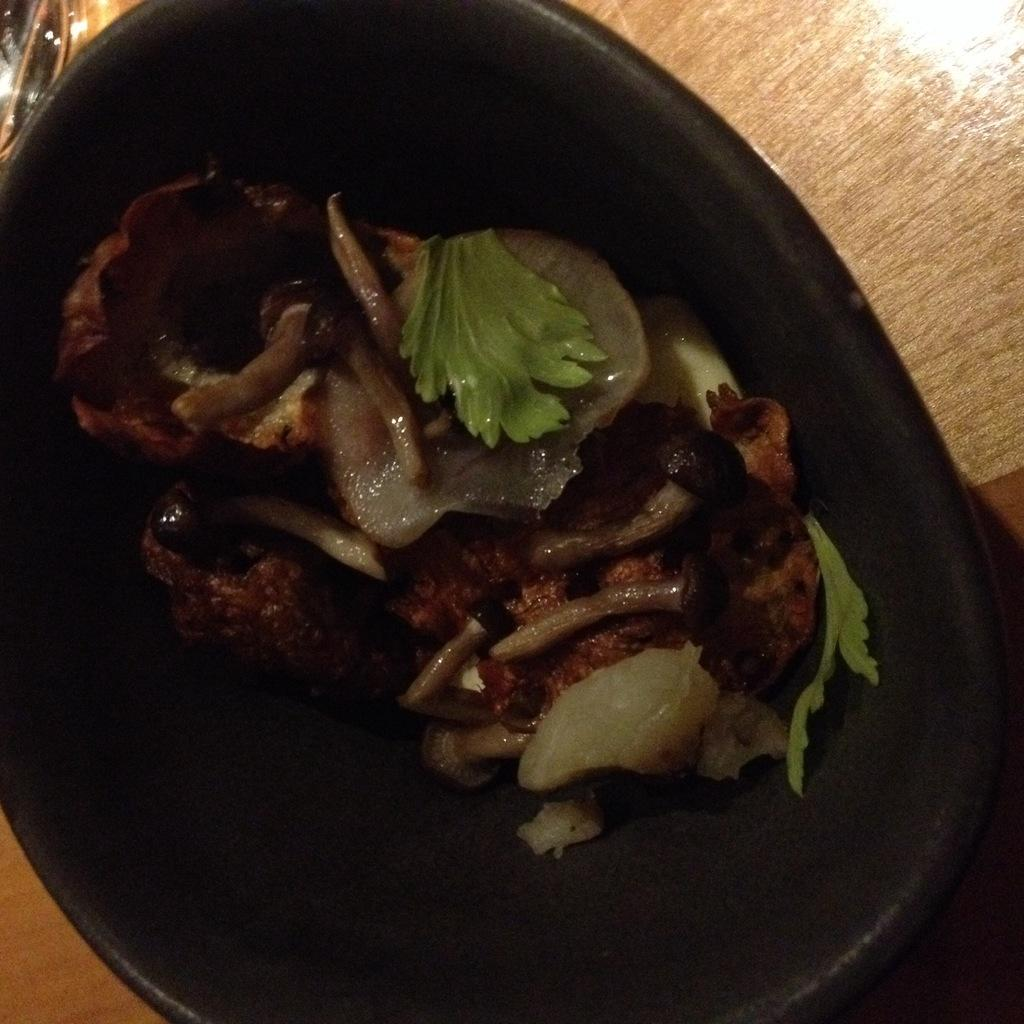What type of bowl is holding the food in the image? The bowl holding the food is black. What color is the surface beneath the black bowl? The wooden surface beneath the black bowl is brown. How many eggs are inside the cap in the image? There is no cap or eggs present in the image. 